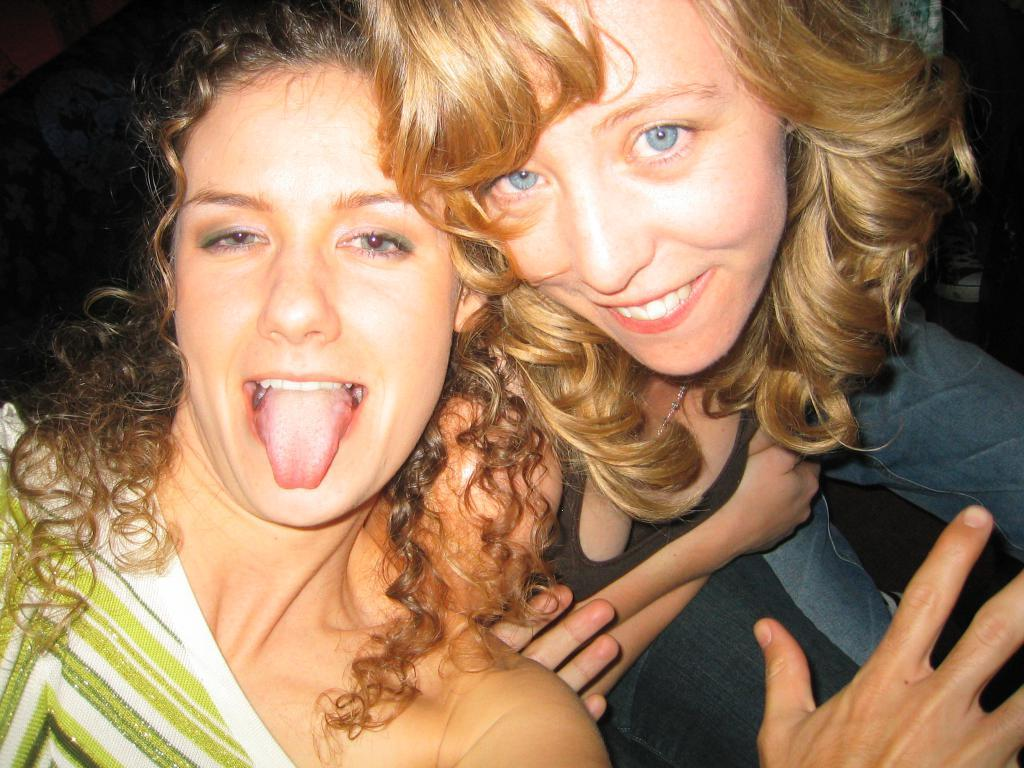How many women are in the image? There are two women in the image. What are the women wearing? One woman is wearing a green and white dress, and the other woman is wearing a blue and black dress. What can be observed about the background of the image? The background of the image is dark. What type of cap is the woman wearing in the image? There is no cap visible in the image; both women are wearing dresses. What message of peace is being conveyed in the image? There is no message of peace or any text present in the image; it only features two women in dresses against a dark background. 